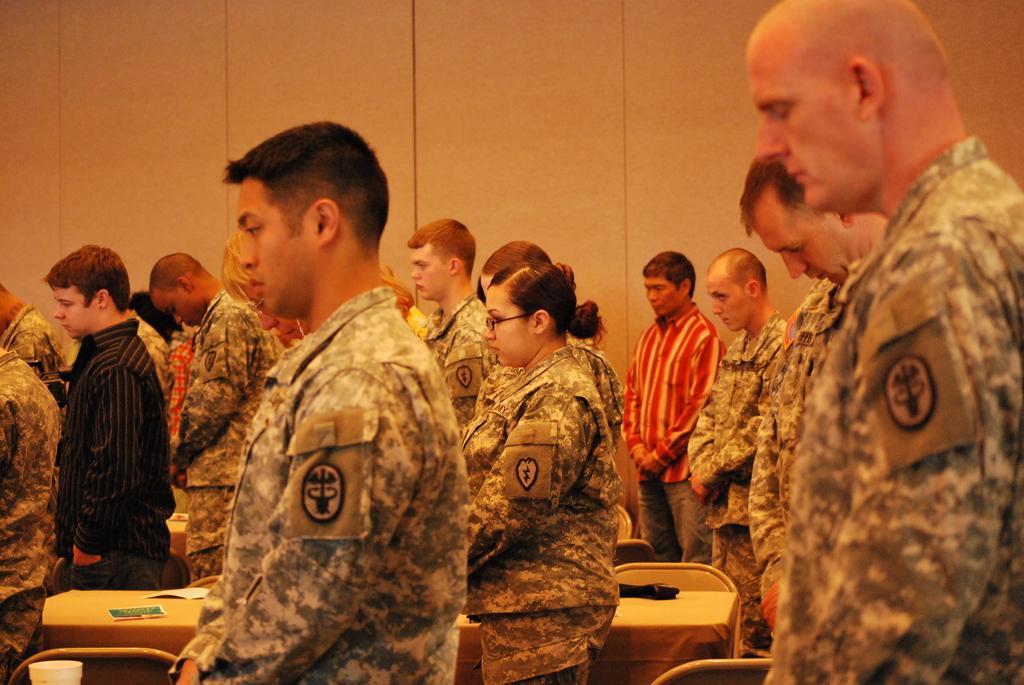Describe this image in one or two sentences. In this image I can see the group of people standing. In these some people are wearing military uniform. In front of these people there is a table. On the table there is a cup and some papers. 